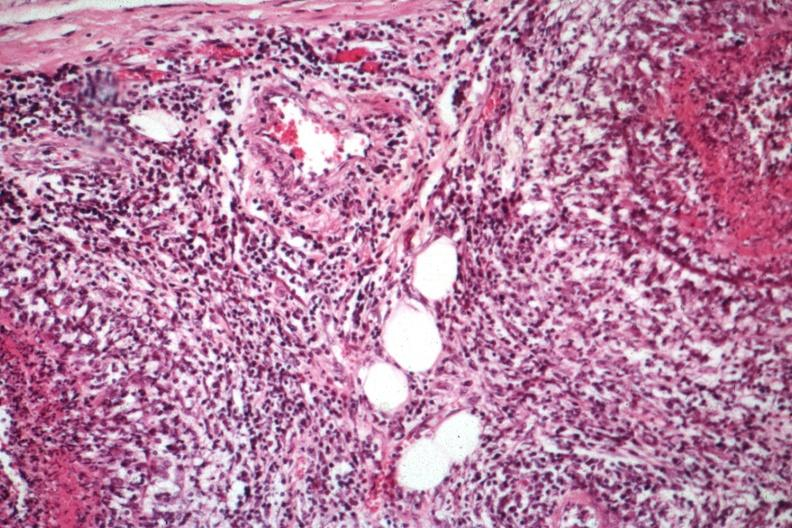what does this image show?
Answer the question using a single word or phrase. Fibrinoid vasculitis and inflammatory cell infiltrative vasculitis well shown 